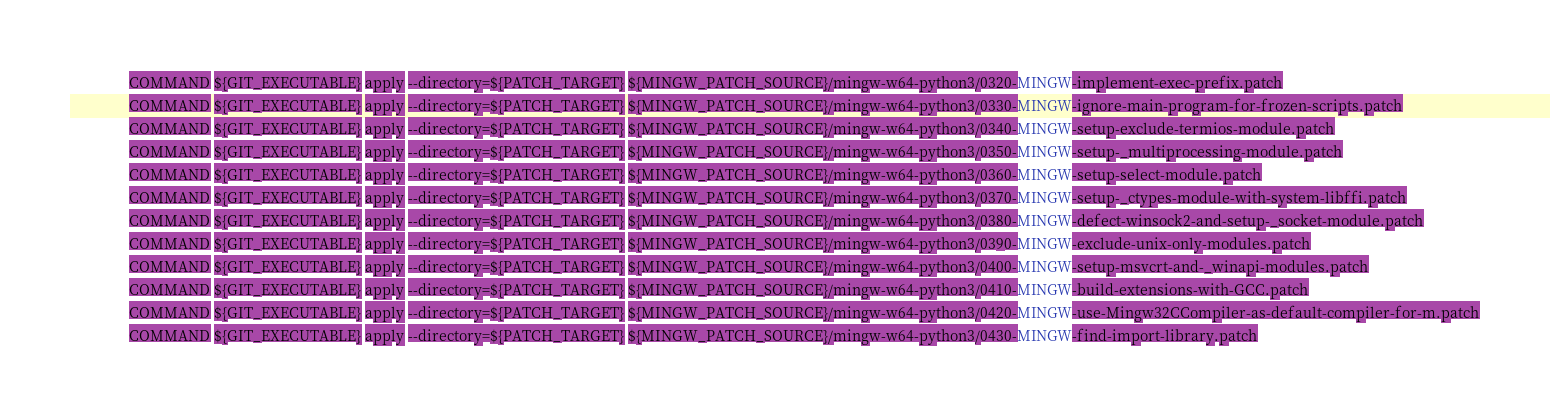<code> <loc_0><loc_0><loc_500><loc_500><_CMake_>				COMMAND ${GIT_EXECUTABLE} apply --directory=${PATCH_TARGET} ${MINGW_PATCH_SOURCE}/mingw-w64-python3/0320-MINGW-implement-exec-prefix.patch
				COMMAND ${GIT_EXECUTABLE} apply --directory=${PATCH_TARGET} ${MINGW_PATCH_SOURCE}/mingw-w64-python3/0330-MINGW-ignore-main-program-for-frozen-scripts.patch
				COMMAND ${GIT_EXECUTABLE} apply --directory=${PATCH_TARGET} ${MINGW_PATCH_SOURCE}/mingw-w64-python3/0340-MINGW-setup-exclude-termios-module.patch
				COMMAND ${GIT_EXECUTABLE} apply --directory=${PATCH_TARGET} ${MINGW_PATCH_SOURCE}/mingw-w64-python3/0350-MINGW-setup-_multiprocessing-module.patch
				COMMAND ${GIT_EXECUTABLE} apply --directory=${PATCH_TARGET} ${MINGW_PATCH_SOURCE}/mingw-w64-python3/0360-MINGW-setup-select-module.patch
				COMMAND ${GIT_EXECUTABLE} apply --directory=${PATCH_TARGET} ${MINGW_PATCH_SOURCE}/mingw-w64-python3/0370-MINGW-setup-_ctypes-module-with-system-libffi.patch
				COMMAND ${GIT_EXECUTABLE} apply --directory=${PATCH_TARGET} ${MINGW_PATCH_SOURCE}/mingw-w64-python3/0380-MINGW-defect-winsock2-and-setup-_socket-module.patch
				COMMAND ${GIT_EXECUTABLE} apply --directory=${PATCH_TARGET} ${MINGW_PATCH_SOURCE}/mingw-w64-python3/0390-MINGW-exclude-unix-only-modules.patch
				COMMAND ${GIT_EXECUTABLE} apply --directory=${PATCH_TARGET} ${MINGW_PATCH_SOURCE}/mingw-w64-python3/0400-MINGW-setup-msvcrt-and-_winapi-modules.patch
				COMMAND ${GIT_EXECUTABLE} apply --directory=${PATCH_TARGET} ${MINGW_PATCH_SOURCE}/mingw-w64-python3/0410-MINGW-build-extensions-with-GCC.patch
				COMMAND ${GIT_EXECUTABLE} apply --directory=${PATCH_TARGET} ${MINGW_PATCH_SOURCE}/mingw-w64-python3/0420-MINGW-use-Mingw32CCompiler-as-default-compiler-for-m.patch
				COMMAND ${GIT_EXECUTABLE} apply --directory=${PATCH_TARGET} ${MINGW_PATCH_SOURCE}/mingw-w64-python3/0430-MINGW-find-import-library.patch</code> 